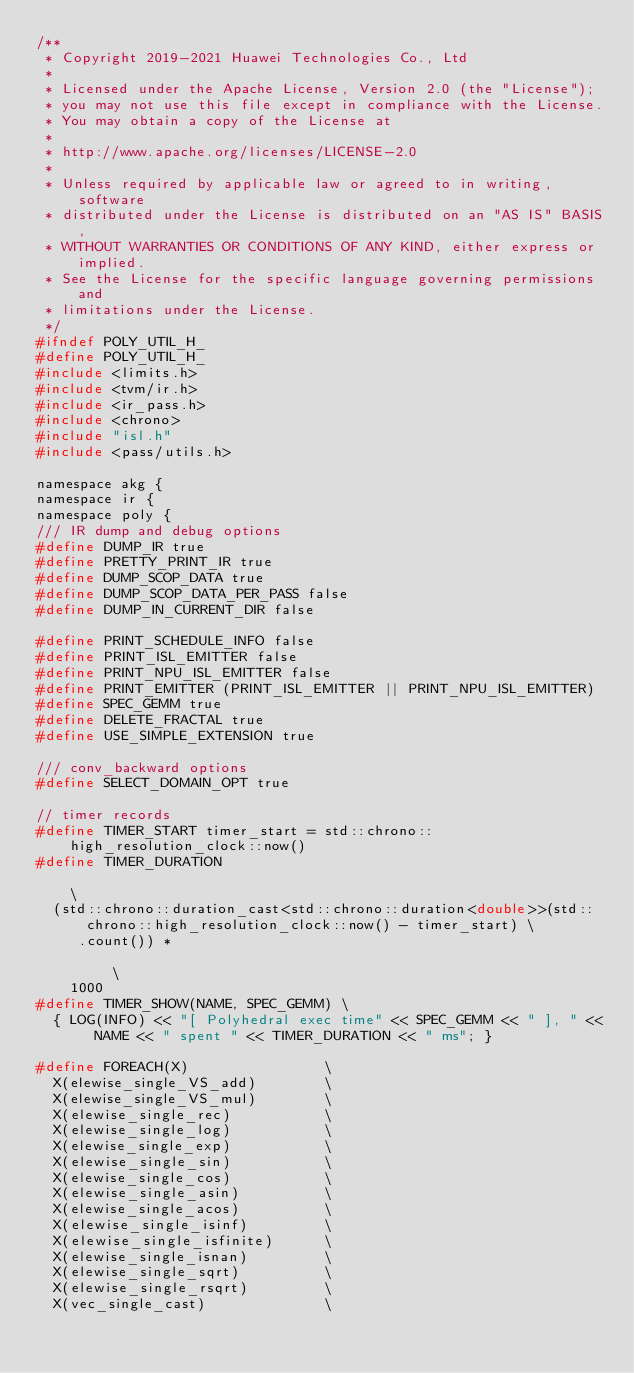<code> <loc_0><loc_0><loc_500><loc_500><_C_>/**
 * Copyright 2019-2021 Huawei Technologies Co., Ltd
 *
 * Licensed under the Apache License, Version 2.0 (the "License");
 * you may not use this file except in compliance with the License.
 * You may obtain a copy of the License at
 *
 * http://www.apache.org/licenses/LICENSE-2.0
 *
 * Unless required by applicable law or agreed to in writing, software
 * distributed under the License is distributed on an "AS IS" BASIS,
 * WITHOUT WARRANTIES OR CONDITIONS OF ANY KIND, either express or implied.
 * See the License for the specific language governing permissions and
 * limitations under the License.
 */
#ifndef POLY_UTIL_H_
#define POLY_UTIL_H_
#include <limits.h>
#include <tvm/ir.h>
#include <ir_pass.h>
#include <chrono>
#include "isl.h"
#include <pass/utils.h>

namespace akg {
namespace ir {
namespace poly {
/// IR dump and debug options
#define DUMP_IR true
#define PRETTY_PRINT_IR true
#define DUMP_SCOP_DATA true
#define DUMP_SCOP_DATA_PER_PASS false
#define DUMP_IN_CURRENT_DIR false

#define PRINT_SCHEDULE_INFO false
#define PRINT_ISL_EMITTER false
#define PRINT_NPU_ISL_EMITTER false
#define PRINT_EMITTER (PRINT_ISL_EMITTER || PRINT_NPU_ISL_EMITTER)
#define SPEC_GEMM true
#define DELETE_FRACTAL true
#define USE_SIMPLE_EXTENSION true

/// conv_backward options
#define SELECT_DOMAIN_OPT true

// timer records
#define TIMER_START timer_start = std::chrono::high_resolution_clock::now()
#define TIMER_DURATION                                                                                                \
  (std::chrono::duration_cast<std::chrono::duration<double>>(std::chrono::high_resolution_clock::now() - timer_start) \
     .count()) *                                                                                                      \
    1000
#define TIMER_SHOW(NAME, SPEC_GEMM) \
  { LOG(INFO) << "[ Polyhedral exec time" << SPEC_GEMM << " ], " << NAME << " spent " << TIMER_DURATION << " ms"; }

#define FOREACH(X)                \
  X(elewise_single_VS_add)        \
  X(elewise_single_VS_mul)        \
  X(elewise_single_rec)           \
  X(elewise_single_log)           \
  X(elewise_single_exp)           \
  X(elewise_single_sin)           \
  X(elewise_single_cos)           \
  X(elewise_single_asin)          \
  X(elewise_single_acos)          \
  X(elewise_single_isinf)         \
  X(elewise_single_isfinite)      \
  X(elewise_single_isnan)         \
  X(elewise_single_sqrt)          \
  X(elewise_single_rsqrt)         \
  X(vec_single_cast)              \</code> 